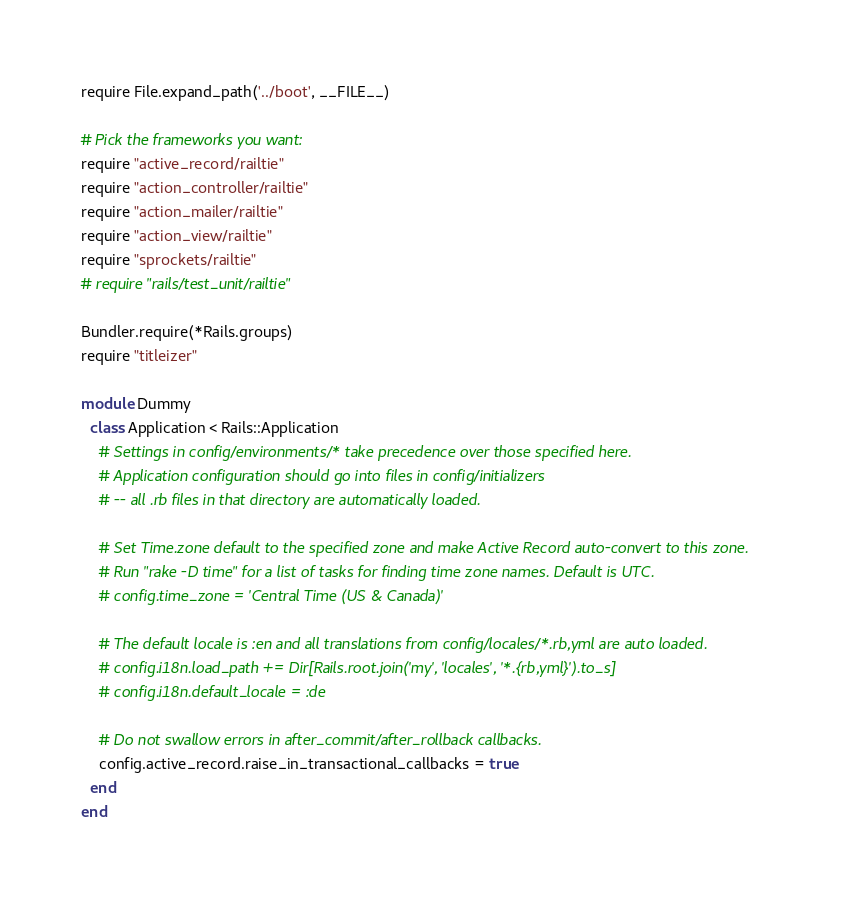<code> <loc_0><loc_0><loc_500><loc_500><_Ruby_>require File.expand_path('../boot', __FILE__)

# Pick the frameworks you want:
require "active_record/railtie"
require "action_controller/railtie"
require "action_mailer/railtie"
require "action_view/railtie"
require "sprockets/railtie"
# require "rails/test_unit/railtie"

Bundler.require(*Rails.groups)
require "titleizer"

module Dummy
  class Application < Rails::Application
    # Settings in config/environments/* take precedence over those specified here.
    # Application configuration should go into files in config/initializers
    # -- all .rb files in that directory are automatically loaded.

    # Set Time.zone default to the specified zone and make Active Record auto-convert to this zone.
    # Run "rake -D time" for a list of tasks for finding time zone names. Default is UTC.
    # config.time_zone = 'Central Time (US & Canada)'

    # The default locale is :en and all translations from config/locales/*.rb,yml are auto loaded.
    # config.i18n.load_path += Dir[Rails.root.join('my', 'locales', '*.{rb,yml}').to_s]
    # config.i18n.default_locale = :de

    # Do not swallow errors in after_commit/after_rollback callbacks.
    config.active_record.raise_in_transactional_callbacks = true
  end
end
</code> 